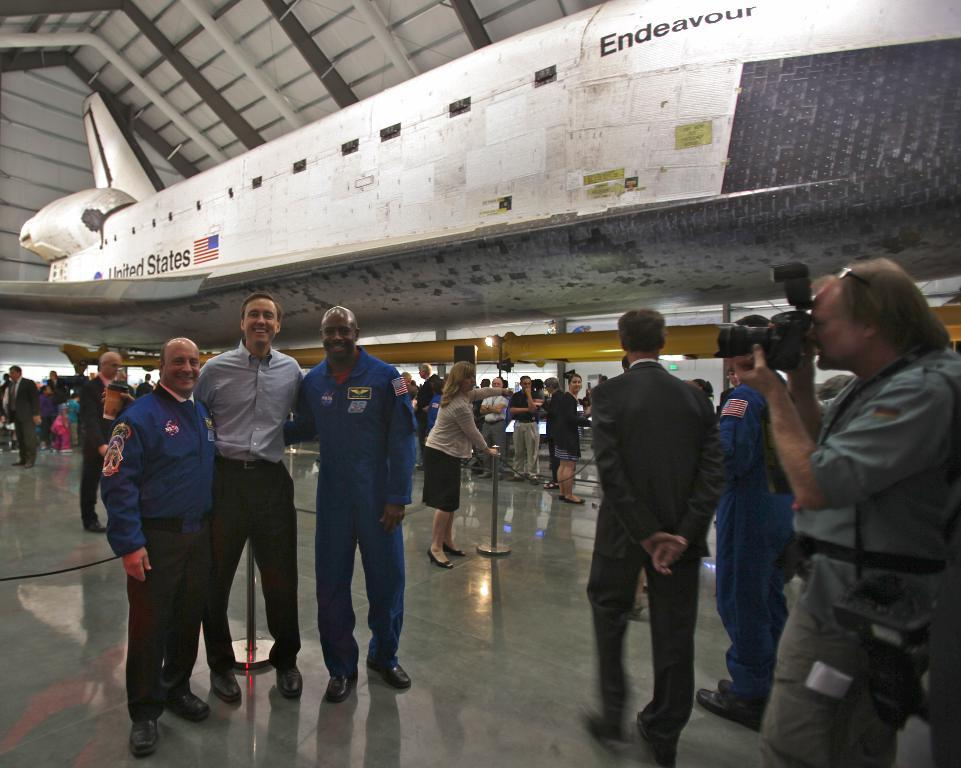<image>
Give a short and clear explanation of the subsequent image. People pose in front of the United States space shuttle Endeavor. 